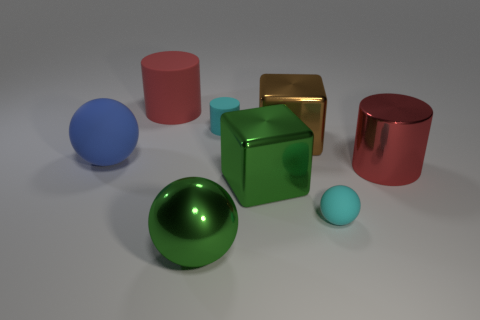Can you tell me which objects in the image are spheres and describe their appearance? Certainly! There are two spheres in the image. One is large and green with a shiny surface, while the other is smaller and blue with a matte finish. 